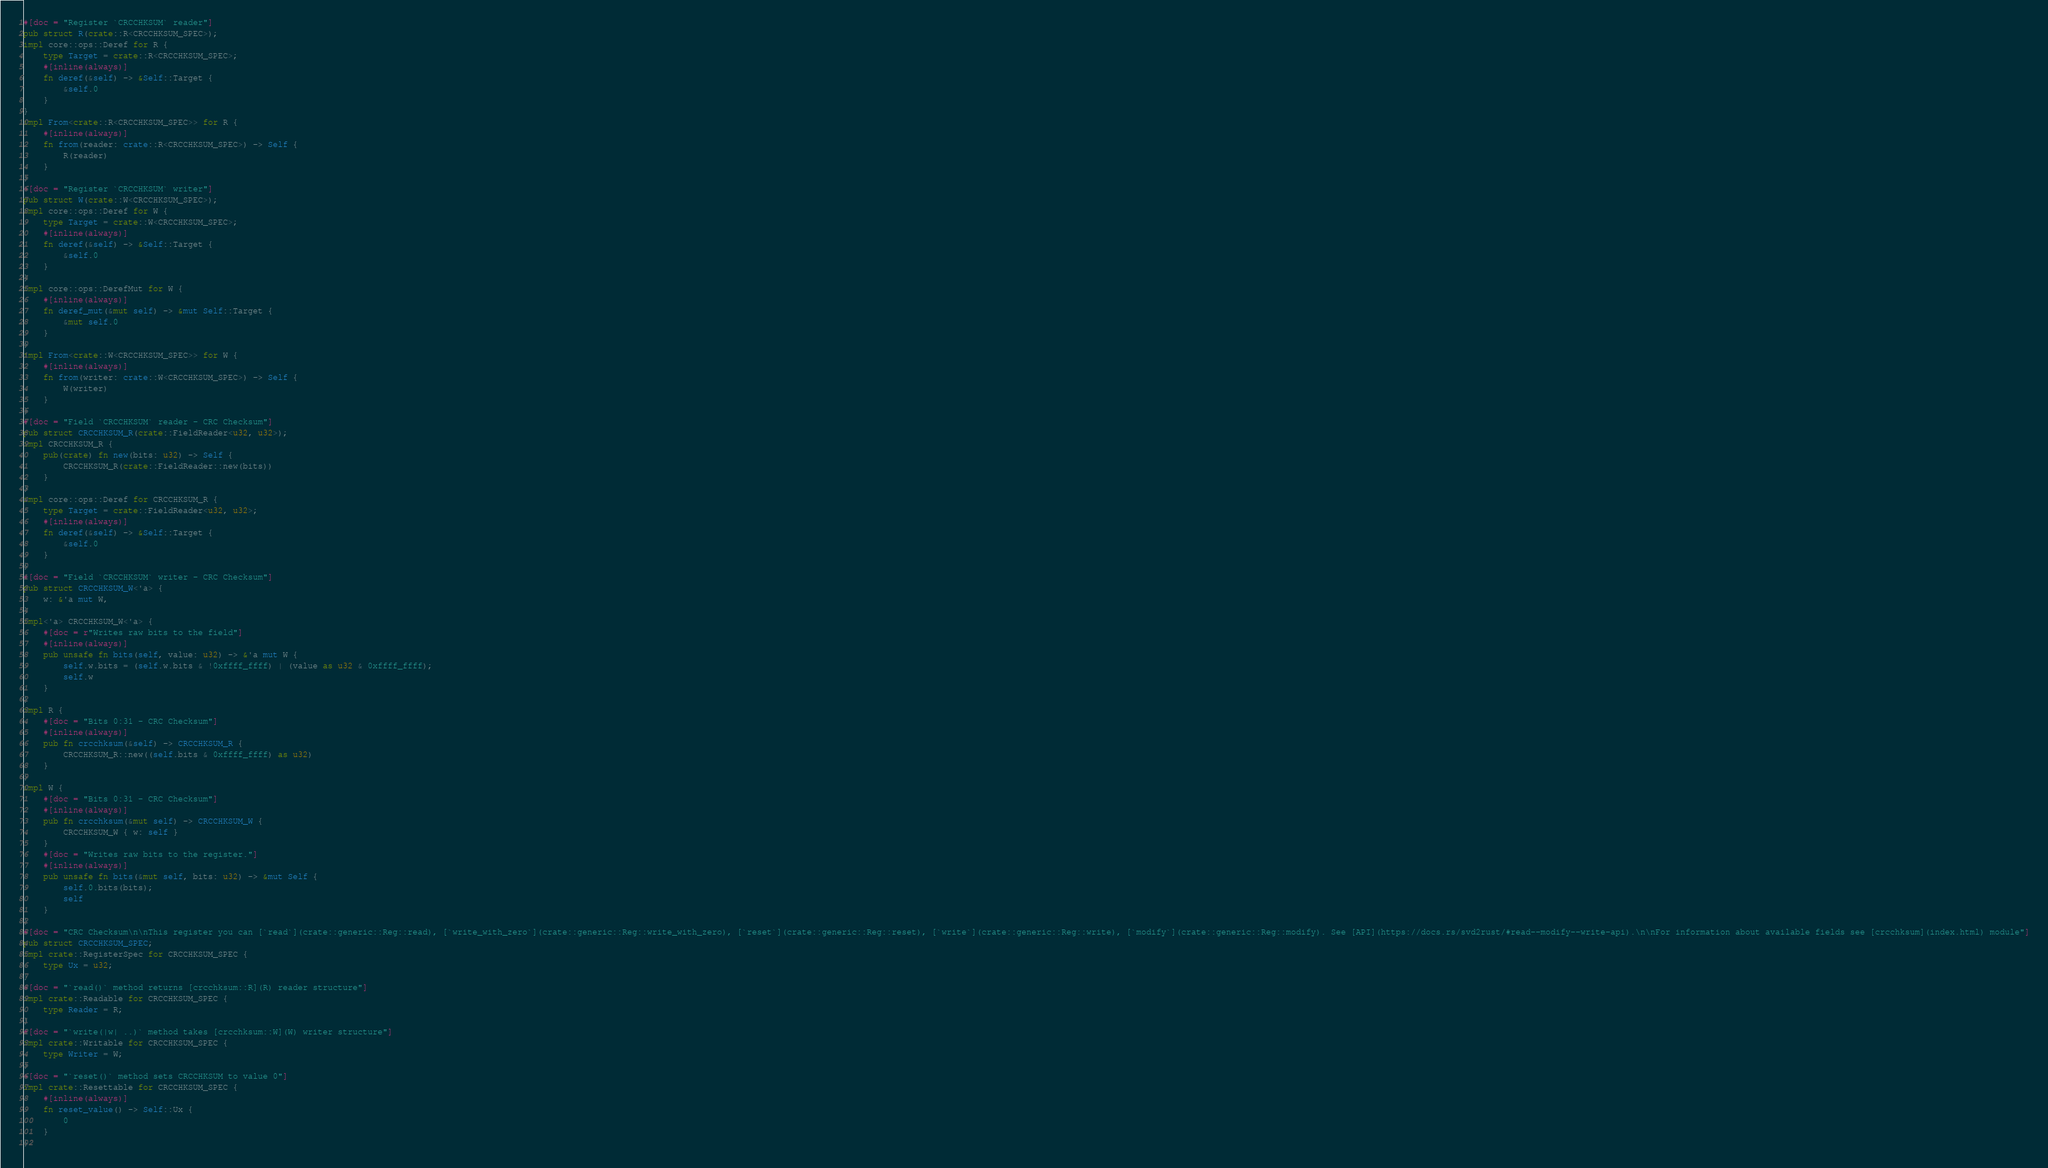Convert code to text. <code><loc_0><loc_0><loc_500><loc_500><_Rust_>#[doc = "Register `CRCCHKSUM` reader"]
pub struct R(crate::R<CRCCHKSUM_SPEC>);
impl core::ops::Deref for R {
    type Target = crate::R<CRCCHKSUM_SPEC>;
    #[inline(always)]
    fn deref(&self) -> &Self::Target {
        &self.0
    }
}
impl From<crate::R<CRCCHKSUM_SPEC>> for R {
    #[inline(always)]
    fn from(reader: crate::R<CRCCHKSUM_SPEC>) -> Self {
        R(reader)
    }
}
#[doc = "Register `CRCCHKSUM` writer"]
pub struct W(crate::W<CRCCHKSUM_SPEC>);
impl core::ops::Deref for W {
    type Target = crate::W<CRCCHKSUM_SPEC>;
    #[inline(always)]
    fn deref(&self) -> &Self::Target {
        &self.0
    }
}
impl core::ops::DerefMut for W {
    #[inline(always)]
    fn deref_mut(&mut self) -> &mut Self::Target {
        &mut self.0
    }
}
impl From<crate::W<CRCCHKSUM_SPEC>> for W {
    #[inline(always)]
    fn from(writer: crate::W<CRCCHKSUM_SPEC>) -> Self {
        W(writer)
    }
}
#[doc = "Field `CRCCHKSUM` reader - CRC Checksum"]
pub struct CRCCHKSUM_R(crate::FieldReader<u32, u32>);
impl CRCCHKSUM_R {
    pub(crate) fn new(bits: u32) -> Self {
        CRCCHKSUM_R(crate::FieldReader::new(bits))
    }
}
impl core::ops::Deref for CRCCHKSUM_R {
    type Target = crate::FieldReader<u32, u32>;
    #[inline(always)]
    fn deref(&self) -> &Self::Target {
        &self.0
    }
}
#[doc = "Field `CRCCHKSUM` writer - CRC Checksum"]
pub struct CRCCHKSUM_W<'a> {
    w: &'a mut W,
}
impl<'a> CRCCHKSUM_W<'a> {
    #[doc = r"Writes raw bits to the field"]
    #[inline(always)]
    pub unsafe fn bits(self, value: u32) -> &'a mut W {
        self.w.bits = (self.w.bits & !0xffff_ffff) | (value as u32 & 0xffff_ffff);
        self.w
    }
}
impl R {
    #[doc = "Bits 0:31 - CRC Checksum"]
    #[inline(always)]
    pub fn crcchksum(&self) -> CRCCHKSUM_R {
        CRCCHKSUM_R::new((self.bits & 0xffff_ffff) as u32)
    }
}
impl W {
    #[doc = "Bits 0:31 - CRC Checksum"]
    #[inline(always)]
    pub fn crcchksum(&mut self) -> CRCCHKSUM_W {
        CRCCHKSUM_W { w: self }
    }
    #[doc = "Writes raw bits to the register."]
    #[inline(always)]
    pub unsafe fn bits(&mut self, bits: u32) -> &mut Self {
        self.0.bits(bits);
        self
    }
}
#[doc = "CRC Checksum\n\nThis register you can [`read`](crate::generic::Reg::read), [`write_with_zero`](crate::generic::Reg::write_with_zero), [`reset`](crate::generic::Reg::reset), [`write`](crate::generic::Reg::write), [`modify`](crate::generic::Reg::modify). See [API](https://docs.rs/svd2rust/#read--modify--write-api).\n\nFor information about available fields see [crcchksum](index.html) module"]
pub struct CRCCHKSUM_SPEC;
impl crate::RegisterSpec for CRCCHKSUM_SPEC {
    type Ux = u32;
}
#[doc = "`read()` method returns [crcchksum::R](R) reader structure"]
impl crate::Readable for CRCCHKSUM_SPEC {
    type Reader = R;
}
#[doc = "`write(|w| ..)` method takes [crcchksum::W](W) writer structure"]
impl crate::Writable for CRCCHKSUM_SPEC {
    type Writer = W;
}
#[doc = "`reset()` method sets CRCCHKSUM to value 0"]
impl crate::Resettable for CRCCHKSUM_SPEC {
    #[inline(always)]
    fn reset_value() -> Self::Ux {
        0
    }
}
</code> 